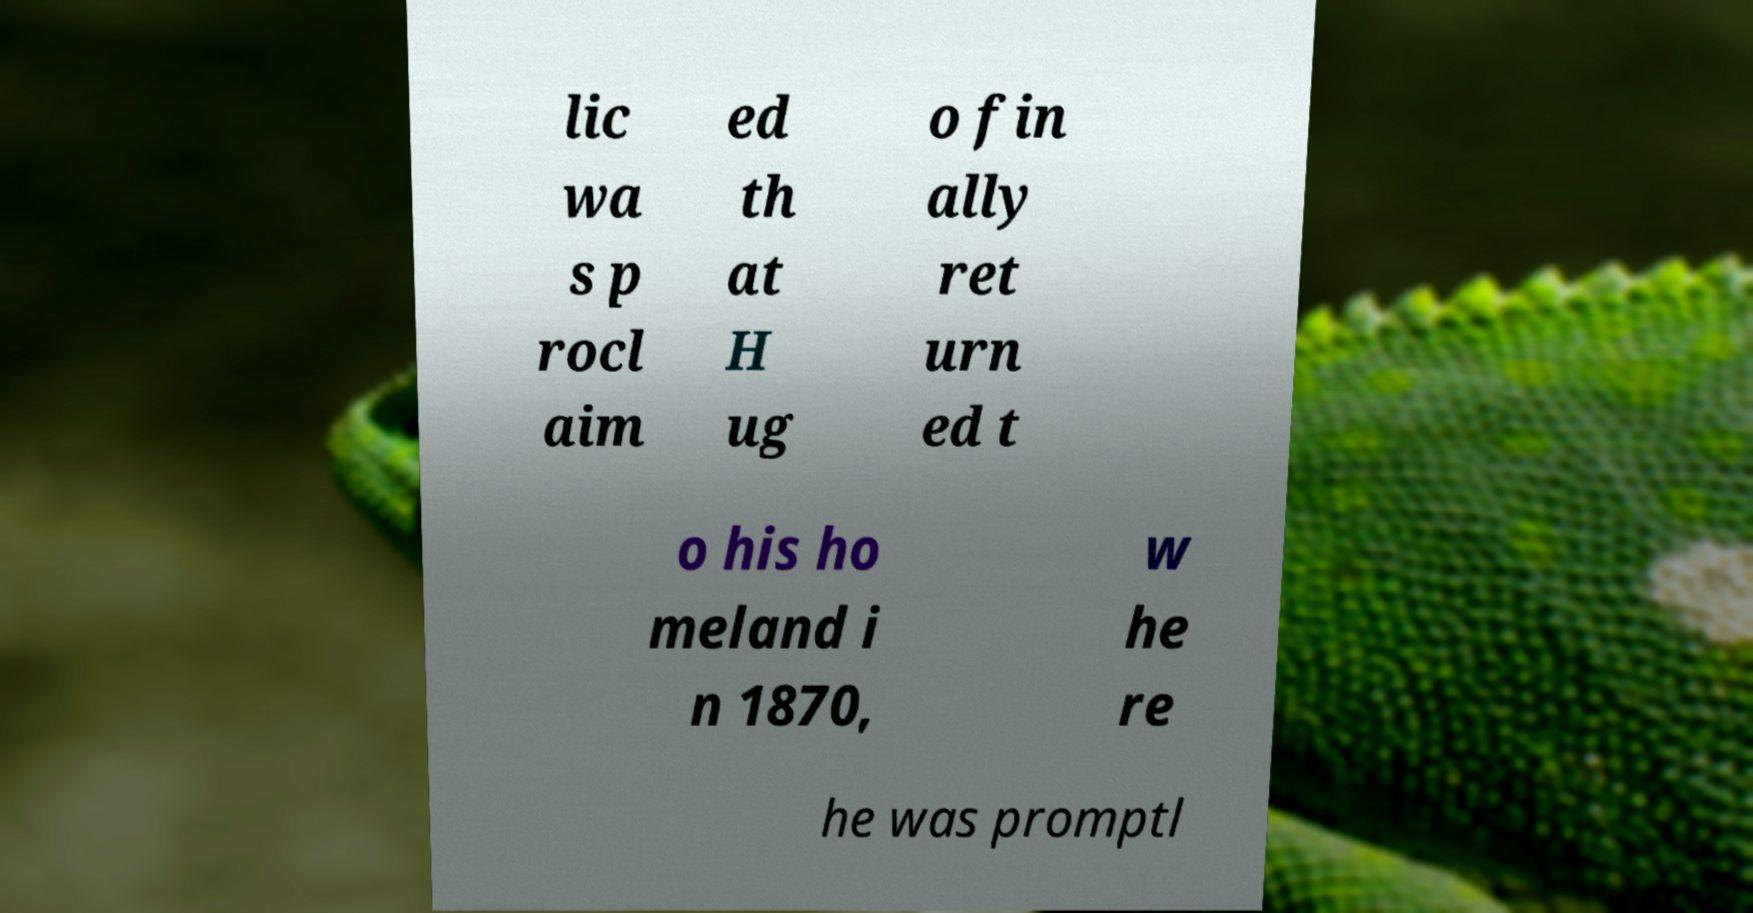For documentation purposes, I need the text within this image transcribed. Could you provide that? lic wa s p rocl aim ed th at H ug o fin ally ret urn ed t o his ho meland i n 1870, w he re he was promptl 